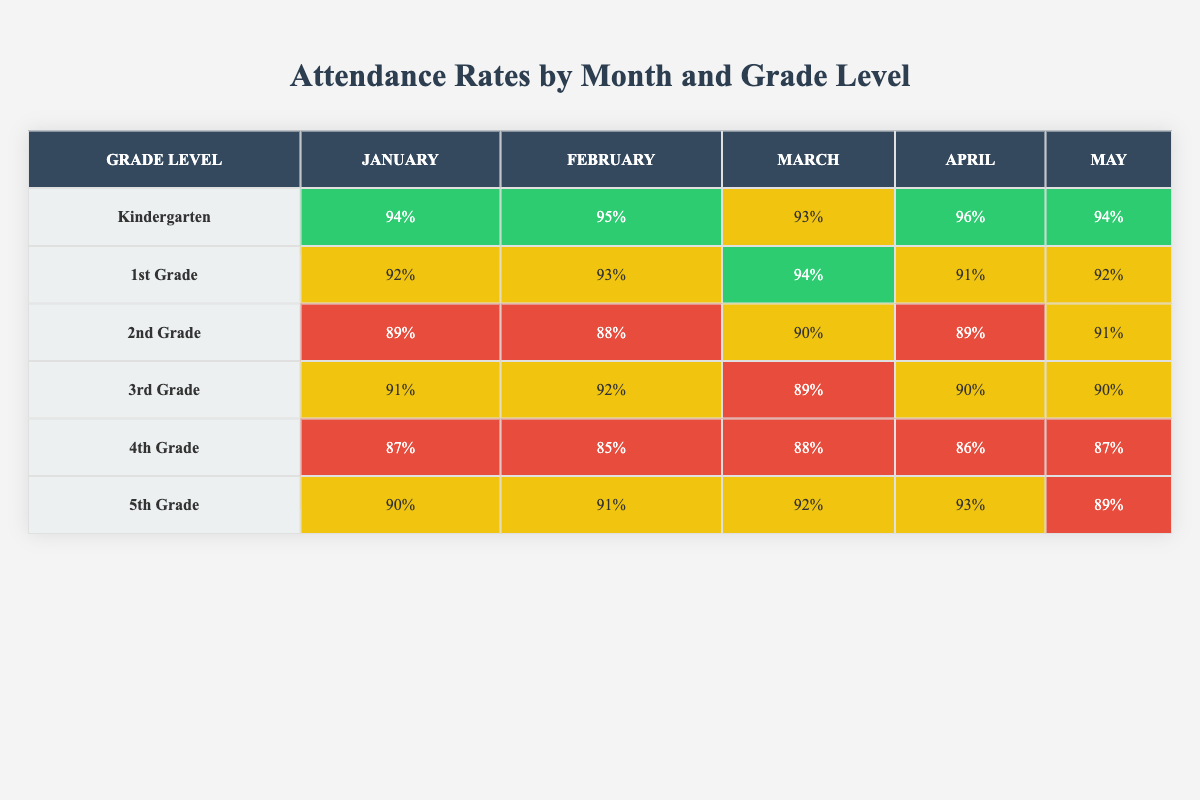What is the highest attendance rate recorded in January? Referring to the table, the highest attendance rate for any grade in January is found in Kindergarten, which has an attendance rate of 94%.
Answer: 94% Which grade had the lowest attendance in February? In the February row, 4th Grade has the lowest attendance rate at 85%.
Answer: 4th Grade What is the average attendance rate for 3rd Grade across all months? The attendance rates for 3rd Grade for each month are: 91% in January, 92% in February, 89% in March, 90% in April, and 90% in May. Adding these rates gives 91 + 92 + 89 + 90 + 90 = 452. Dividing by the number of months (5) results in an average of 452/5 = 90.4%.
Answer: 90.4% Is the attendance rate for 5th Grade consistently above 90% in March, April, and May? Checking the table for 5th Grade, the attendance rates are 92% in March, 93% in April, and 89% in May. The rates for March and April are above 90%, but May is below 90%. Therefore, 5th Grade does not have consistently above 90% attendance in these months.
Answer: No In which month did Kindergarten achieve its highest attendance rate? By examining the Kindergarten row, the attendance rates are 94% in January, 95% in February, 93% in March, 96% in April, and 94% in May. The highest attendance rate for Kindergarten was 96% in April.
Answer: April What is the difference in attendance rates between 2nd Grade in January and May? For 2nd Grade, the attendance rate is 89% in January and 91% in May. To find the difference: 91 - 89 = 2. Thus, the difference in attendance rates is 2%.
Answer: 2% Which grade had the most significant drop in attendance from January to April? Evaluating each grade from January to April, we see 4th Grade dropped from 87% in January to 86% in April, which is a decrease of 1%. The most significant drop was observed in 2nd Grade from 89% in January to 89% in April, which remains the same, resulting in a 0% drop. Therefore, the largest drop is in 4th Grade by 1%.
Answer: 4th Grade Are there any months where all grade levels had an attendance rate of above 90%? By inspecting each month's attendance rates, we can see that in January and February, Kindergarten, 1st Grade, and 5th Grade have attendance over 90%, while 2nd, 3rd, and 4th Grade do not. Thus, no month has all grades above 90%.
Answer: No 